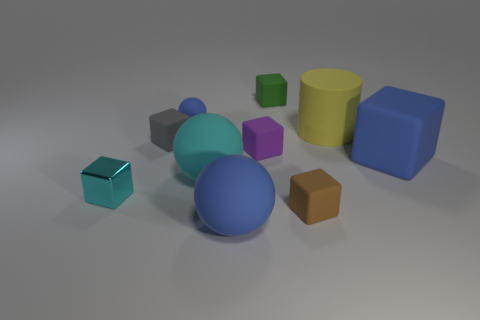There is a large object that is in front of the small shiny cube behind the big blue rubber object that is in front of the small shiny block; what shape is it?
Provide a short and direct response. Sphere. The big matte thing that is the same color as the metal cube is what shape?
Keep it short and to the point. Sphere. How many shiny cubes are the same size as the brown object?
Ensure brevity in your answer.  1. Is there a blue matte thing that is behind the cyan thing behind the tiny cyan metal cube?
Your response must be concise. Yes. What number of objects are tiny brown matte things or tiny gray shiny cylinders?
Your answer should be very brief. 1. What color is the rubber sphere that is to the left of the large cyan rubber object on the left side of the blue ball on the right side of the small blue matte object?
Your response must be concise. Blue. Is there any other thing that has the same color as the tiny matte ball?
Offer a terse response. Yes. Do the yellow rubber cylinder and the purple object have the same size?
Provide a succinct answer. No. How many things are either rubber objects that are in front of the gray matte cube or matte spheres behind the small brown cube?
Give a very brief answer. 6. There is a big blue object that is on the right side of the blue object that is in front of the cyan matte ball; what is its material?
Make the answer very short. Rubber. 